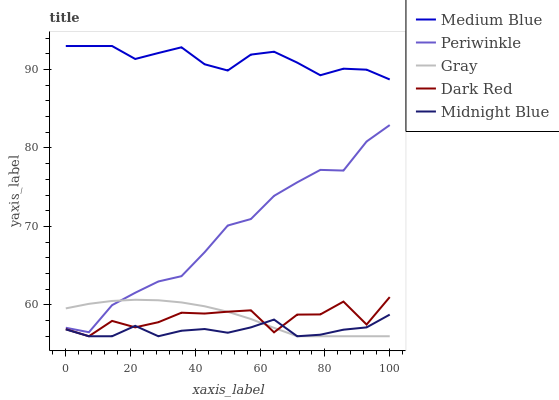Does Dark Red have the minimum area under the curve?
Answer yes or no. No. Does Dark Red have the maximum area under the curve?
Answer yes or no. No. Is Medium Blue the smoothest?
Answer yes or no. No. Is Medium Blue the roughest?
Answer yes or no. No. Does Medium Blue have the lowest value?
Answer yes or no. No. Does Dark Red have the highest value?
Answer yes or no. No. Is Dark Red less than Periwinkle?
Answer yes or no. Yes. Is Periwinkle greater than Dark Red?
Answer yes or no. Yes. Does Dark Red intersect Periwinkle?
Answer yes or no. No. 